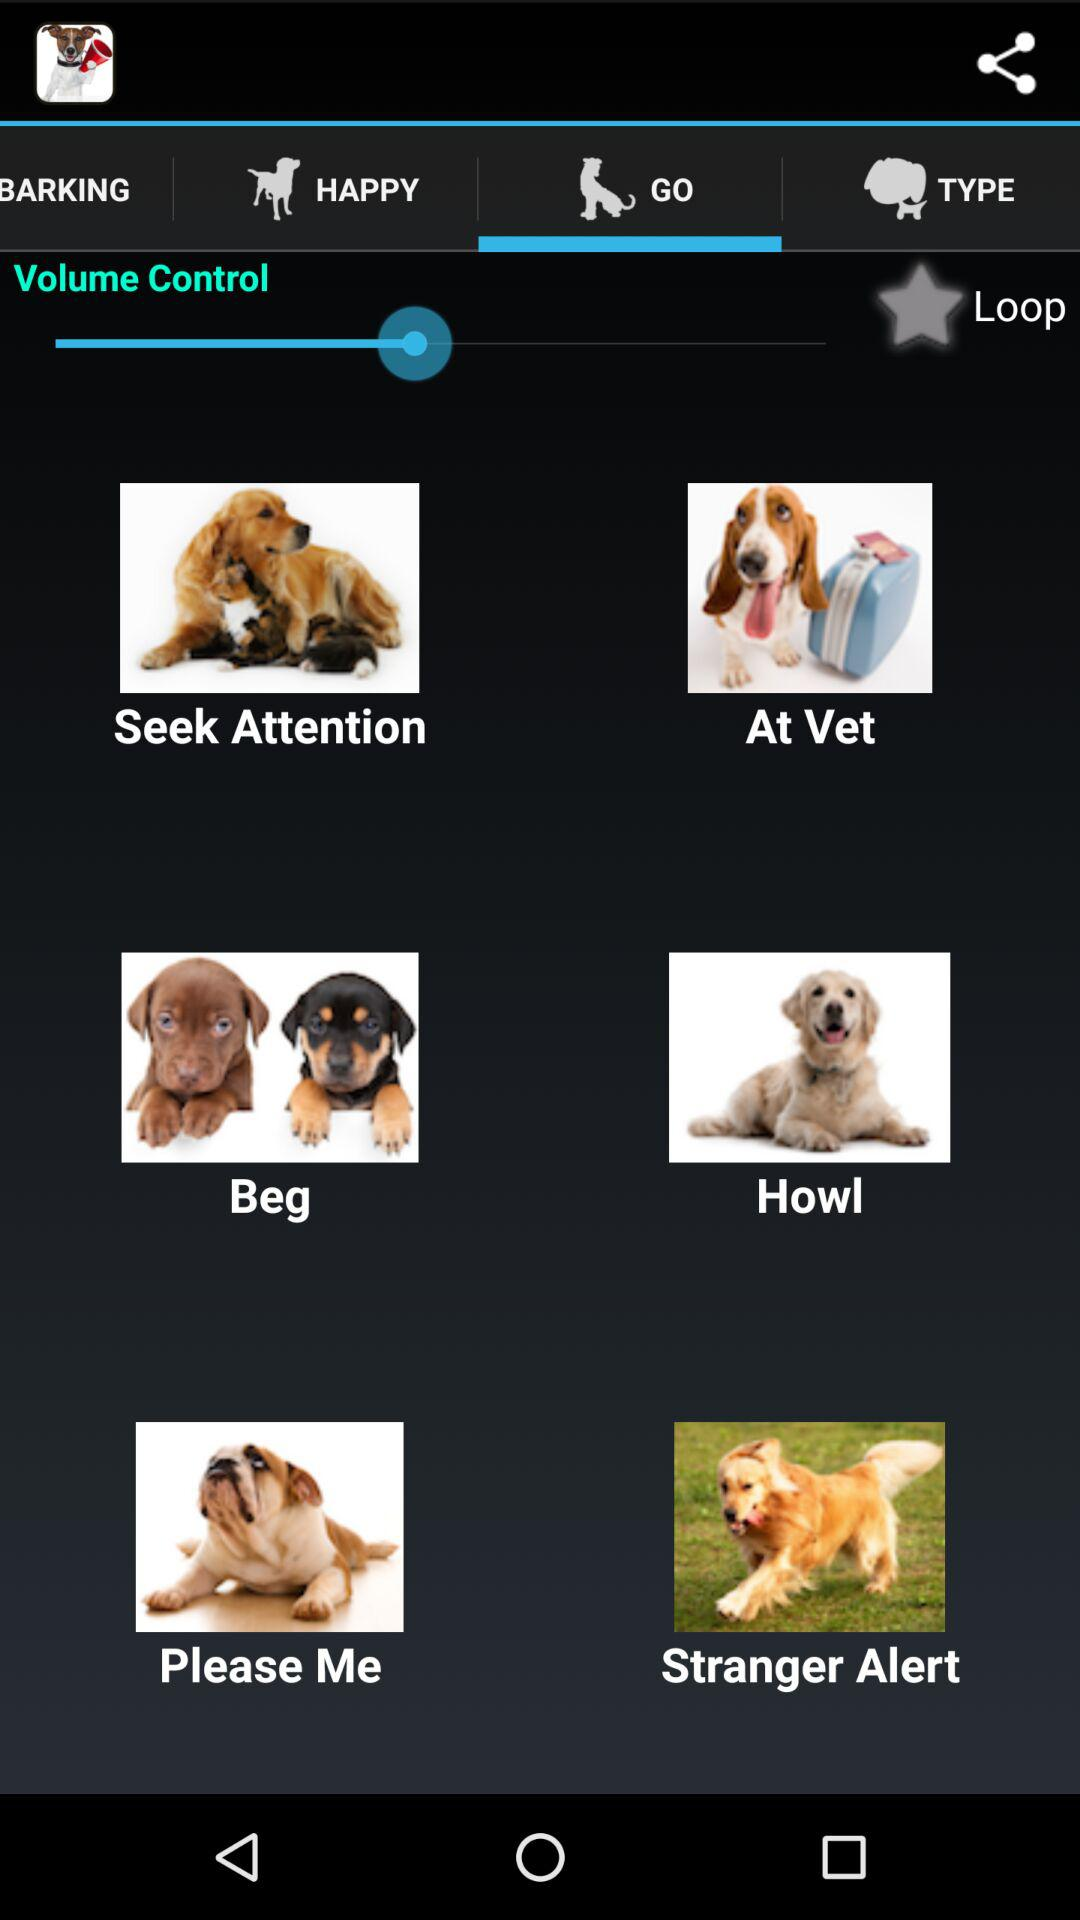Which tab has been selected? The tab "GO" has been selected. 